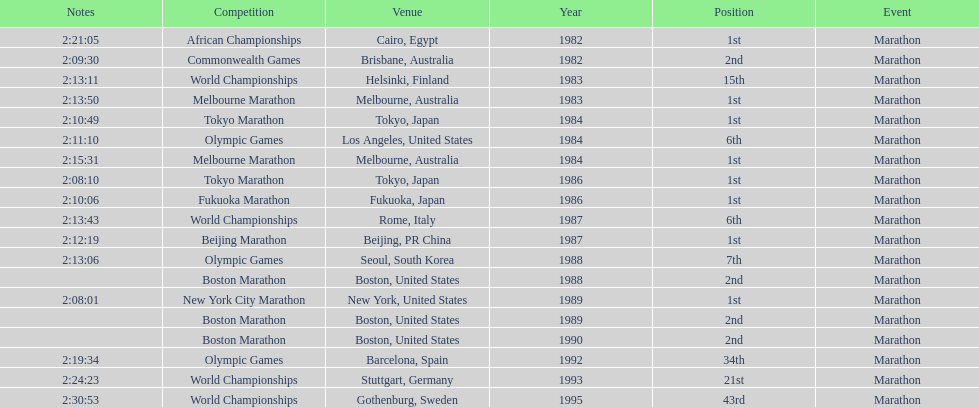Which was the only competition to occur in china? Beijing Marathon. 